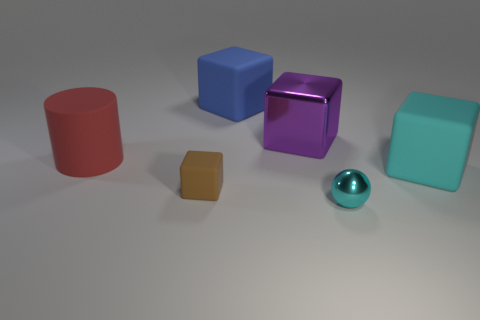Do the thing behind the purple block and the small brown object have the same material?
Make the answer very short. Yes. Are there any other things that are the same size as the red object?
Keep it short and to the point. Yes. Are there fewer big red objects that are behind the red rubber cylinder than purple metallic blocks that are behind the small shiny object?
Keep it short and to the point. Yes. Is there any other thing that has the same shape as the large red rubber object?
Your answer should be compact. No. There is a big object that is the same color as the shiny ball; what is its material?
Provide a succinct answer. Rubber. What number of big purple objects are in front of the cyan thing that is to the left of the matte cube that is to the right of the ball?
Provide a succinct answer. 0. There is a cyan rubber thing; how many matte things are behind it?
Your answer should be very brief. 2. How many cyan spheres are the same material as the cylinder?
Ensure brevity in your answer.  0. There is another tiny object that is the same material as the blue object; what color is it?
Your answer should be very brief. Brown. The big blue block on the left side of the shiny thing that is behind the big matte object that is left of the large blue block is made of what material?
Give a very brief answer. Rubber. 